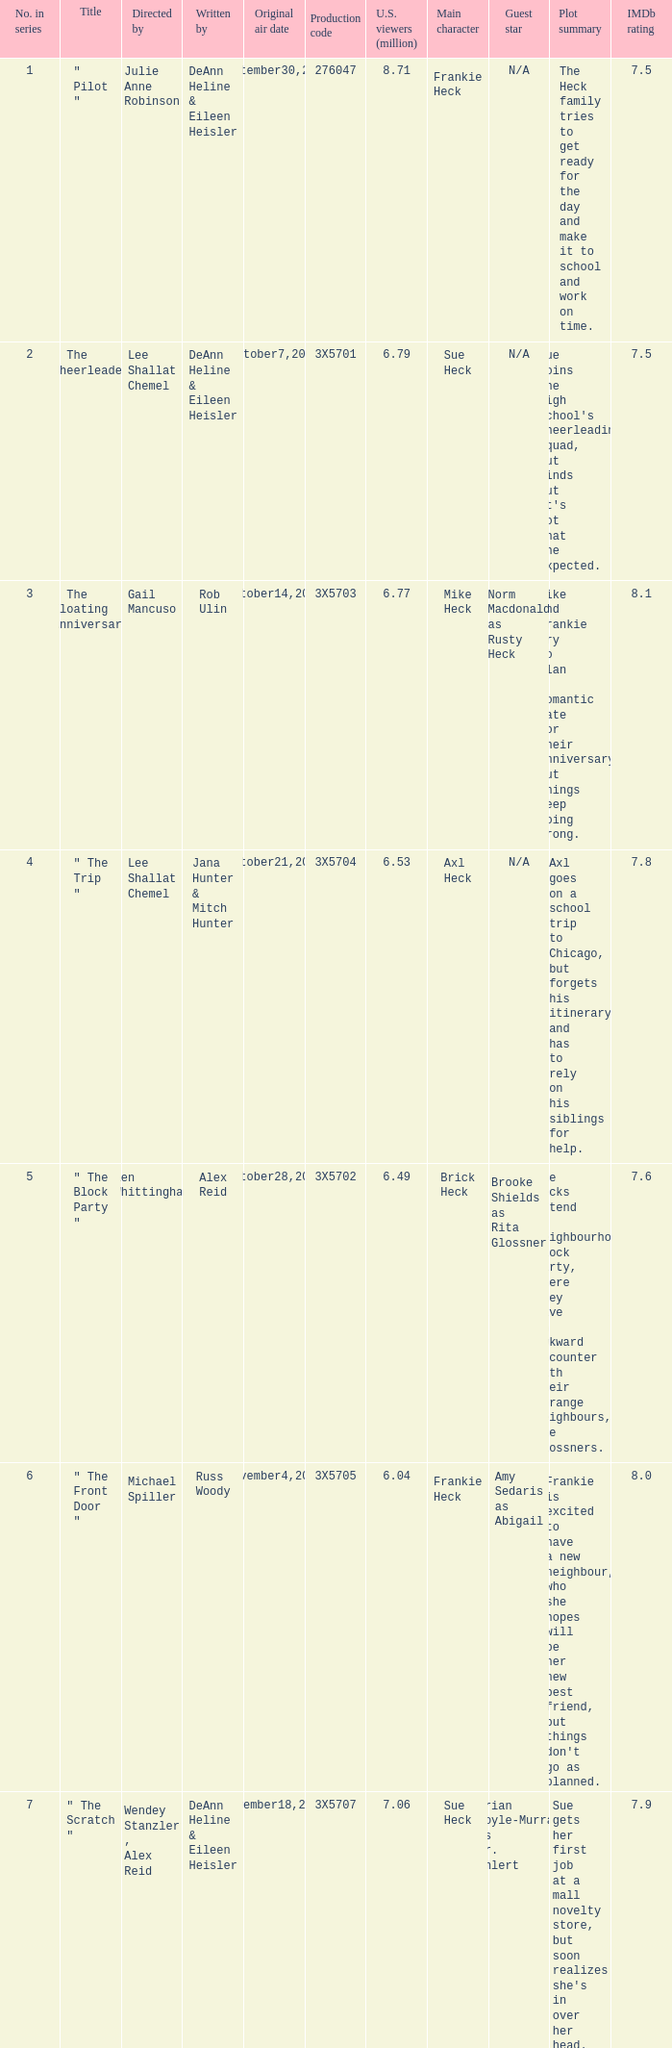How many directors got 6.79 million U.S. viewers from their episodes? 1.0. 